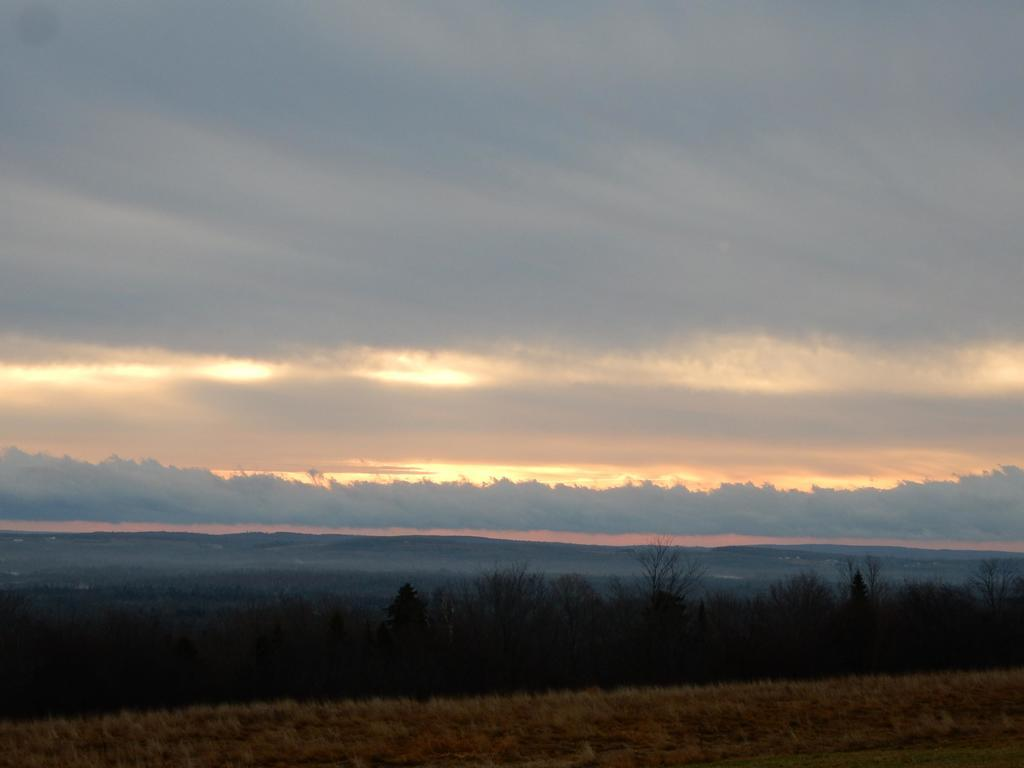What type of terrain is visible in the image? There is land visible in the image. What type of vegetation can be seen in the image? There are plants in the image. What is the condition of the sky in the image? The sky is covered with clouds. Where is the faucet located in the image? There is no faucet present in the image. What type of flag is visible in the image? There is no flag present in the image. 